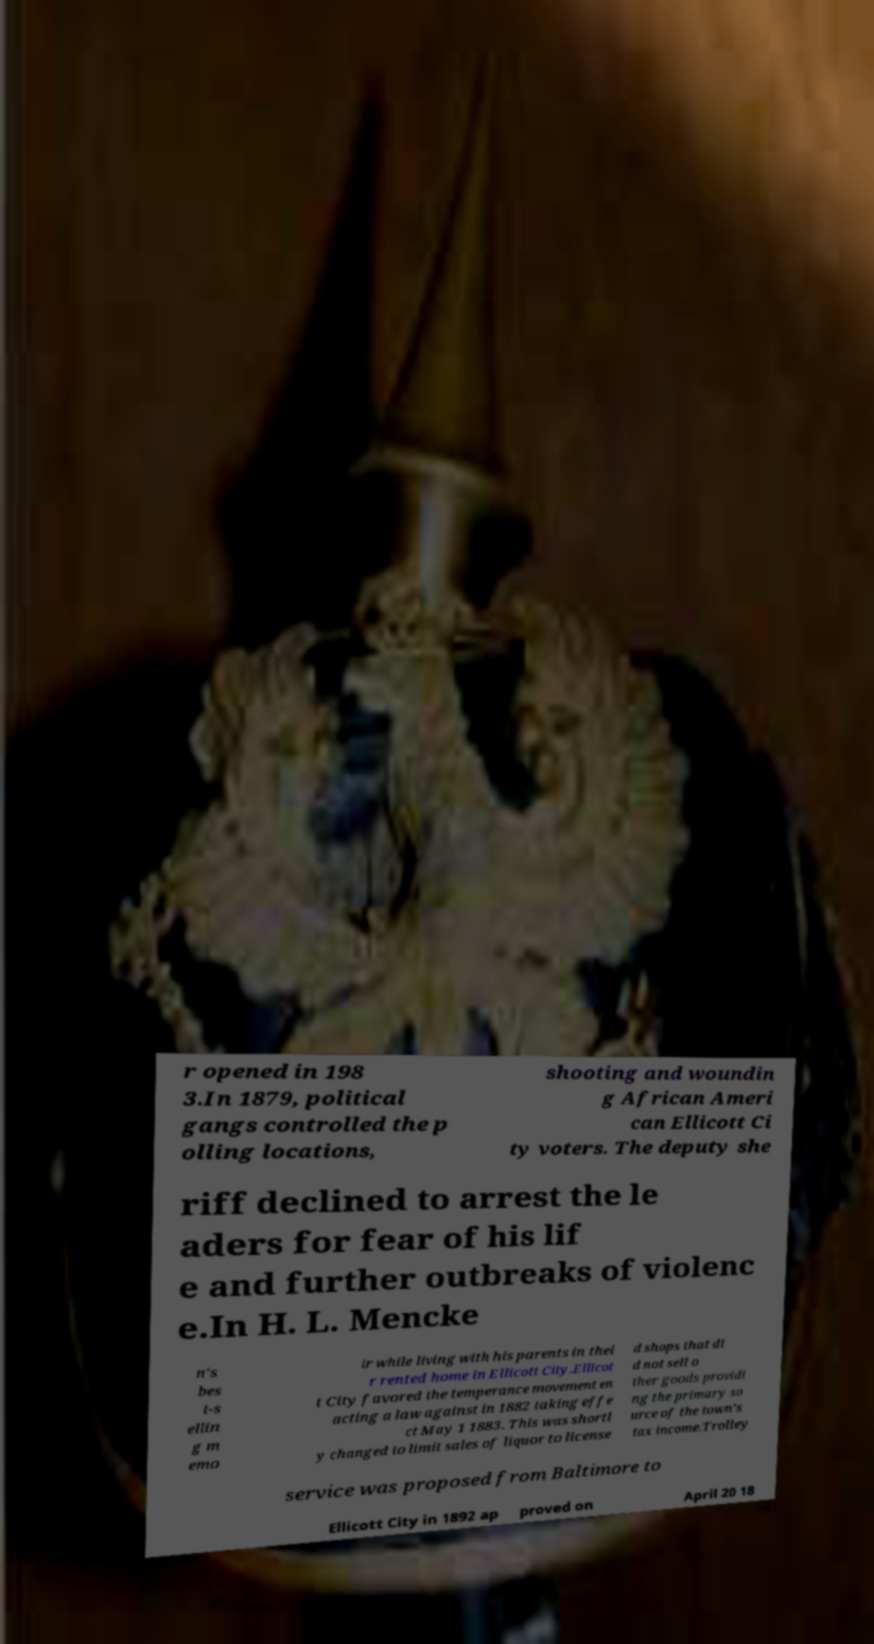Please identify and transcribe the text found in this image. r opened in 198 3.In 1879, political gangs controlled the p olling locations, shooting and woundin g African Ameri can Ellicott Ci ty voters. The deputy she riff declined to arrest the le aders for fear of his lif e and further outbreaks of violenc e.In H. L. Mencke n's bes t-s ellin g m emo ir while living with his parents in thei r rented home in Ellicott City.Ellicot t City favored the temperance movement en acting a law against in 1882 taking effe ct May 1 1883. This was shortl y changed to limit sales of liquor to license d shops that di d not sell o ther goods providi ng the primary so urce of the town's tax income.Trolley service was proposed from Baltimore to Ellicott City in 1892 ap proved on April 20 18 